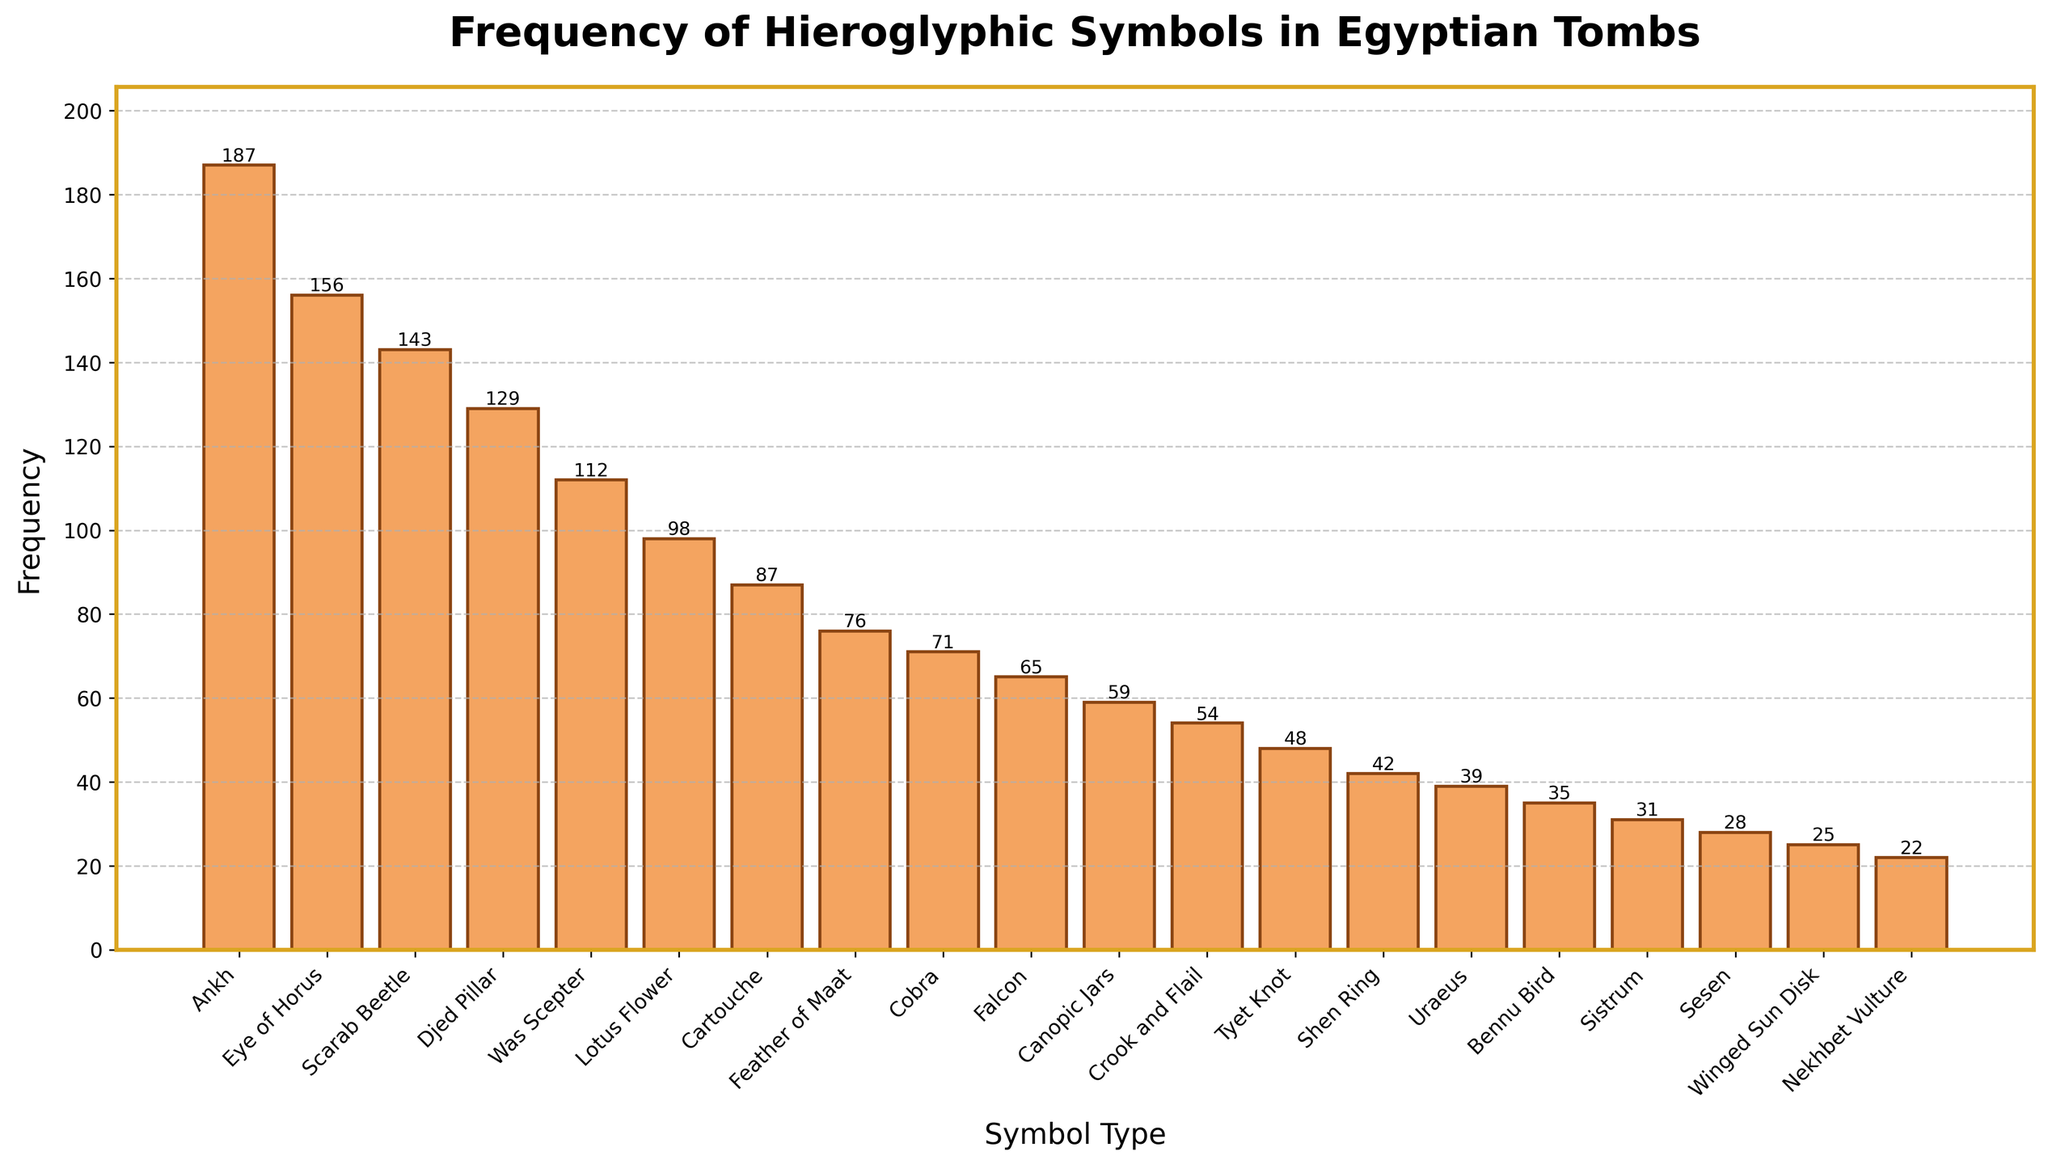What's the most frequent hieroglyphic symbol found in Egyptian tombs? Clearly, the highest bar represents the symbol type 'Ankh' with a frequency of 187.
Answer: Ankh Which symbol has a higher frequency: 'Scarab Beetle' or 'Falcon'? By comparing the lengths of the bars for 'Scarab Beetle' (143) and 'Falcon' (65), it's evident that 'Scarab Beetle' has a higher frequency.
Answer: Scarab Beetle What is the total frequency of the 'Eye of Horus', 'Lotus Flower', and 'Cobra' symbols combined? Adding the frequencies for 'Eye of Horus' (156), 'Lotus Flower' (98), and 'Cobra' (71) results in 156 + 98 + 71 = 325.
Answer: 325 Are there more occurrences of 'Cartouche' than 'Feather of Maat'? Comparing their frequencies, 'Cartouche' has 87 occurrences while 'Feather of Maat' has 76, so 'Cartouche' is more frequent.
Answer: Yes How many symbols have a frequency greater than 100? List them. The symbols with a frequency greater than 100 are 'Ankh' (187), 'Eye of Horus' (156), 'Scarab Beetle' (143), 'Djed Pillar' (129), and 'Was Scepter' (112). Counting them, there are 5 symbols in total.
Answer: 5, Ankh, Eye of Horus, Scarab Beetle, Djed Pillar, Was Scepter What is the frequency difference between the most frequent symbol and the least frequent symbol? The most frequent symbol is 'Ankh' with 187 occurrences, and the least frequent is 'Nekhbet Vulture' with 22 occurrences. The difference is 187 - 22 = 165.
Answer: 165 Which hieroglyphic symbols have frequencies less than 50? List them. The bars for 'Tyet Knot' (48), 'Shen Ring' (42), 'Uraeus' (39), 'Bennu Bird' (35), 'Sistrum' (31), 'Sesen' (28), 'Winged Sun Disk' (25), and 'Nekhbet Vulture' (22) show that these symbols have frequencies less than 50.
Answer: Tyet Knot, Shen Ring, Uraeus, Bennu Bird, Sistrum, Sesen, Winged Sun Disk, Nekhbet Vulture If you combine the frequencies of 'Lotus Flower' and 'Cobra', is the total greater than the frequency of 'Was Scepter'? The combined frequency of 'Lotus Flower' (98) and 'Cobra' (71) is 98 + 71 = 169, which is indeed greater than that of 'Was Scepter' (112).
Answer: Yes How does the frequency of 'Canopic Jars' compare to 'Crook and Flail'? The bar for 'Canopic Jars' shows 59 occurrences, while 'Crook and Flail' has 54 occurrences, making 'Canopic Jars' more frequent.
Answer: Canopic Jars is more frequent 